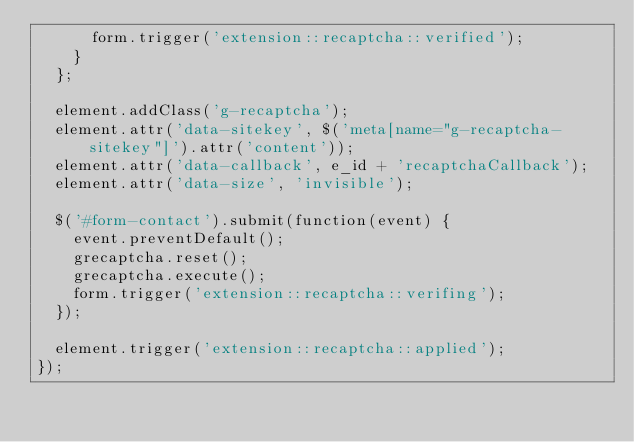Convert code to text. <code><loc_0><loc_0><loc_500><loc_500><_JavaScript_>      form.trigger('extension::recaptcha::verified');
    }
  };

  element.addClass('g-recaptcha');
  element.attr('data-sitekey', $('meta[name="g-recaptcha-sitekey"]').attr('content'));
  element.attr('data-callback', e_id + 'recaptchaCallback');
  element.attr('data-size', 'invisible');

  $('#form-contact').submit(function(event) {
    event.preventDefault();
    grecaptcha.reset();
    grecaptcha.execute();
    form.trigger('extension::recaptcha::verifing');
  });

  element.trigger('extension::recaptcha::applied');
});
</code> 